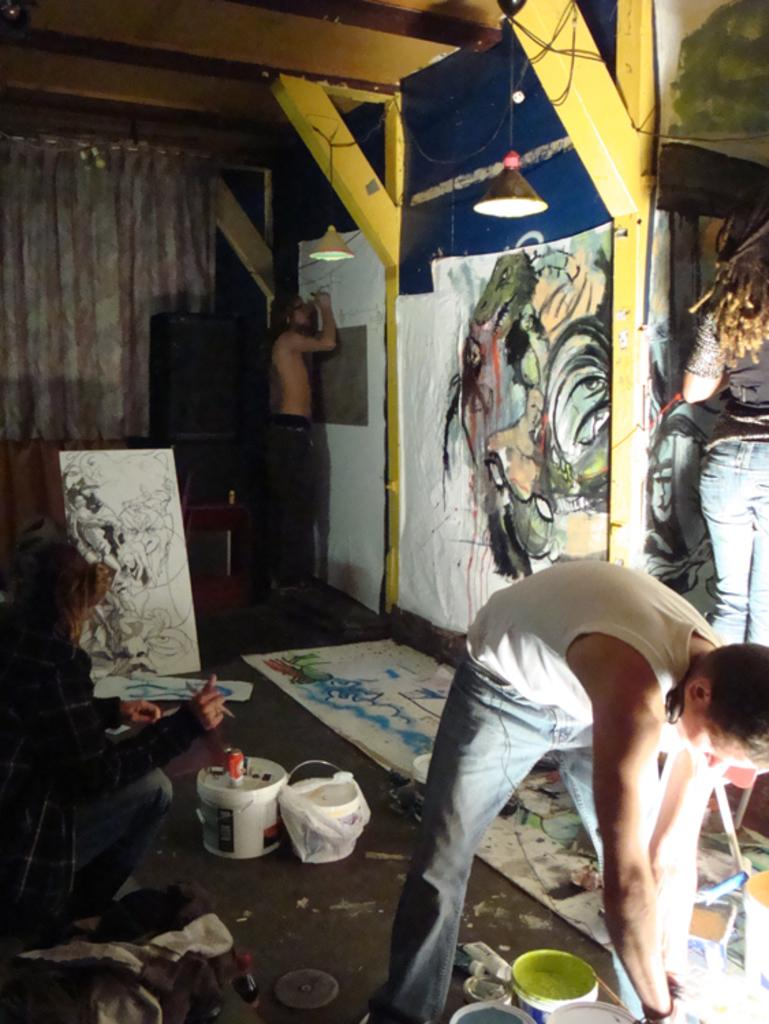How many people are present in the image? There are people in the image, but the exact number is not specified. What can be seen hanging near the people? There are curtains in the image. What device is present for amplifying sound? There is a speaker in the image. What type of lighting is present in the image? There are lights in the image. What objects are used for holding water or other liquids? There are buckets in the image. What type of container is present in the image? There is a bottle in the image. What type of surface is present in the image? There are boards in the image. What type of artwork is present on the boards? There are paintings on the boards. What activity are two people engaged in? Two people are doing painting on the boards. What type of thrill can be seen in the alley in the image? There is no alley present in the image, and therefore no thrill can be observed. What type of thunder can be heard coming from the speaker in the image? There is no thunder present in the image, and the speaker is not producing any sound. 